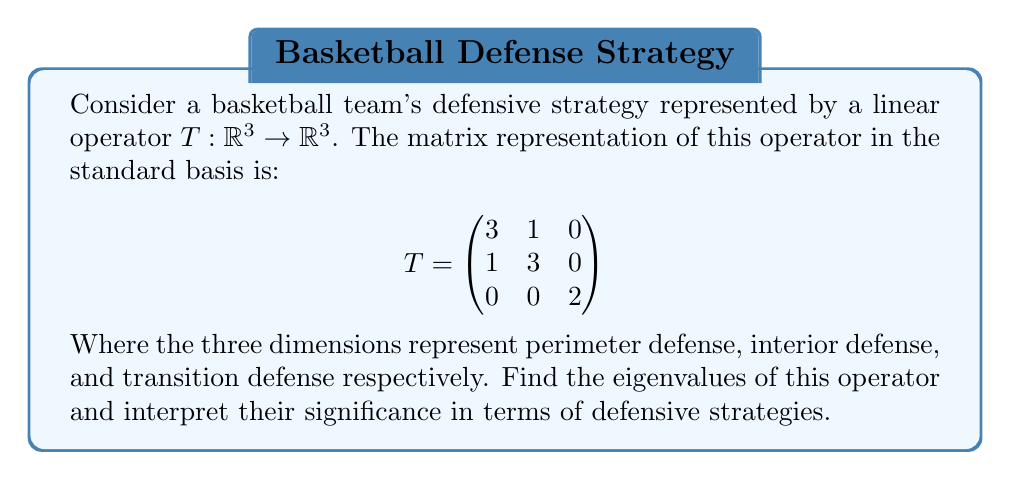What is the answer to this math problem? To find the eigenvalues of the linear operator $T$, we need to solve the characteristic equation:

$$\det(T - \lambda I) = 0$$

Where $I$ is the $3 \times 3$ identity matrix and $\lambda$ represents the eigenvalues.

Step 1: Set up the characteristic equation:

$$
\det \begin{pmatrix}
3-\lambda & 1 & 0 \\
1 & 3-\lambda & 0 \\
0 & 0 & 2-\lambda
\end{pmatrix} = 0
$$

Step 2: Calculate the determinant:

$$(3-\lambda)(3-\lambda)(2-\lambda) - 1(2-\lambda) = 0$$

Step 3: Expand the equation:

$$(9-6\lambda+\lambda^2)(2-\lambda) - (2-\lambda) = 0$$
$$18-9\lambda+2\lambda^2-12\lambda+6\lambda^2-\lambda^3 - 2 + \lambda = 0$$
$$-\lambda^3+8\lambda^2-11\lambda+16 = 0$$

Step 4: Factor the equation:

$$-(\lambda-2)(\lambda-4)(\lambda-2) = 0$$

Step 5: Solve for $\lambda$:

The eigenvalues are $\lambda_1 = 2$ (with algebraic multiplicity 2) and $\lambda_2 = 4$.

Interpretation:
1. $\lambda_1 = 2$ (multiplicity 2): This eigenvalue corresponds to two independent defensive strategies that remain unchanged under the team's defensive system. It likely represents the transition defense (which is already isolated in the matrix) and a combination of perimeter and interior defense that the team maintains consistently.

2. $\lambda_2 = 4$: This larger eigenvalue represents the team's strongest defensive strategy, which is amplified by the system. It's likely a coordinated effort combining perimeter and interior defense, possibly representing the team's ability to effectively switch and help on defense.

The fact that all eigenvalues are positive indicates that the defensive system is stable and reinforces all aspects of the team's defense.
Answer: The eigenvalues of the linear operator $T$ are:
$\lambda_1 = 2$ (with algebraic multiplicity 2)
$\lambda_2 = 4$ 